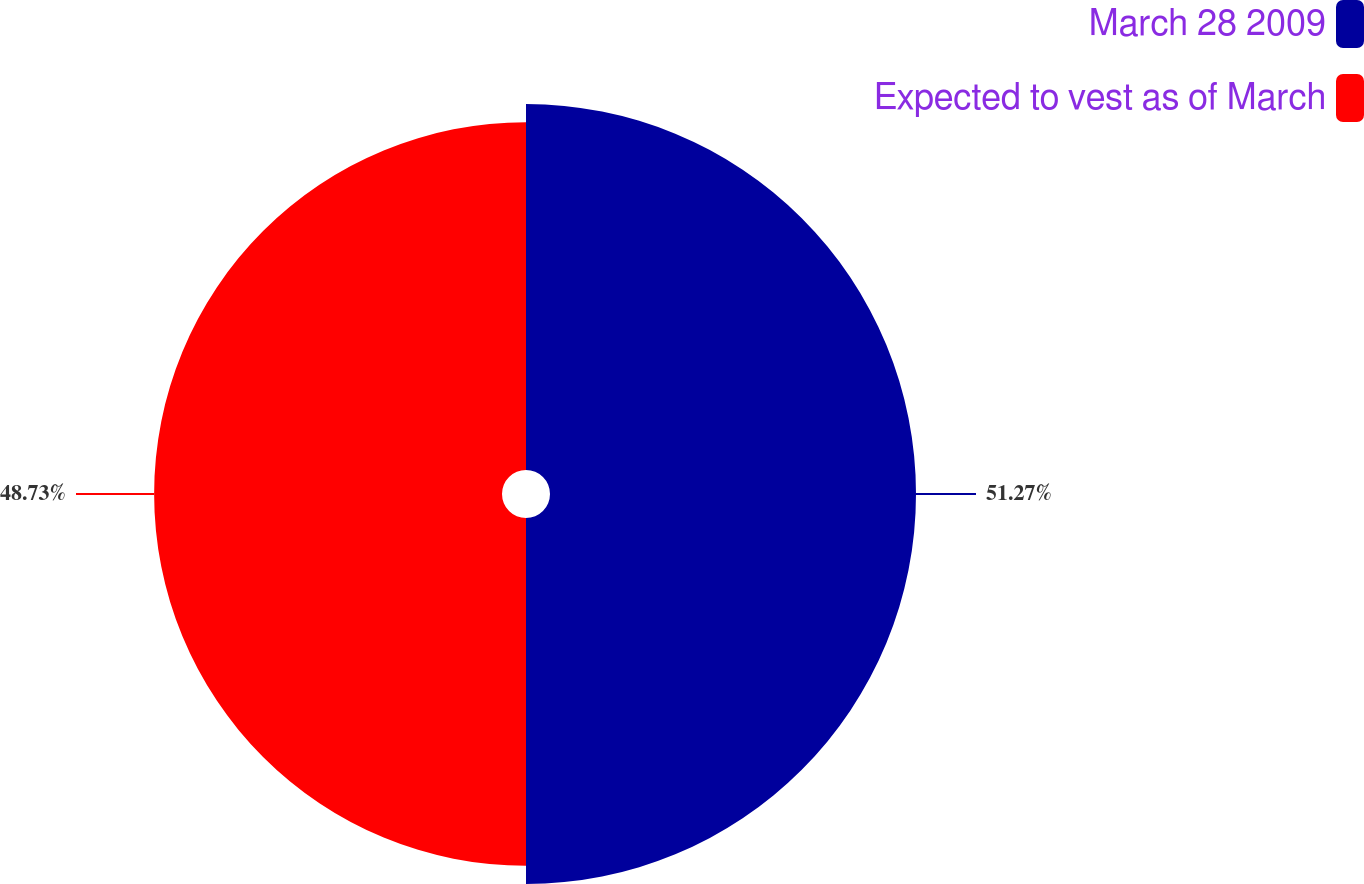<chart> <loc_0><loc_0><loc_500><loc_500><pie_chart><fcel>March 28 2009<fcel>Expected to vest as of March<nl><fcel>51.27%<fcel>48.73%<nl></chart> 